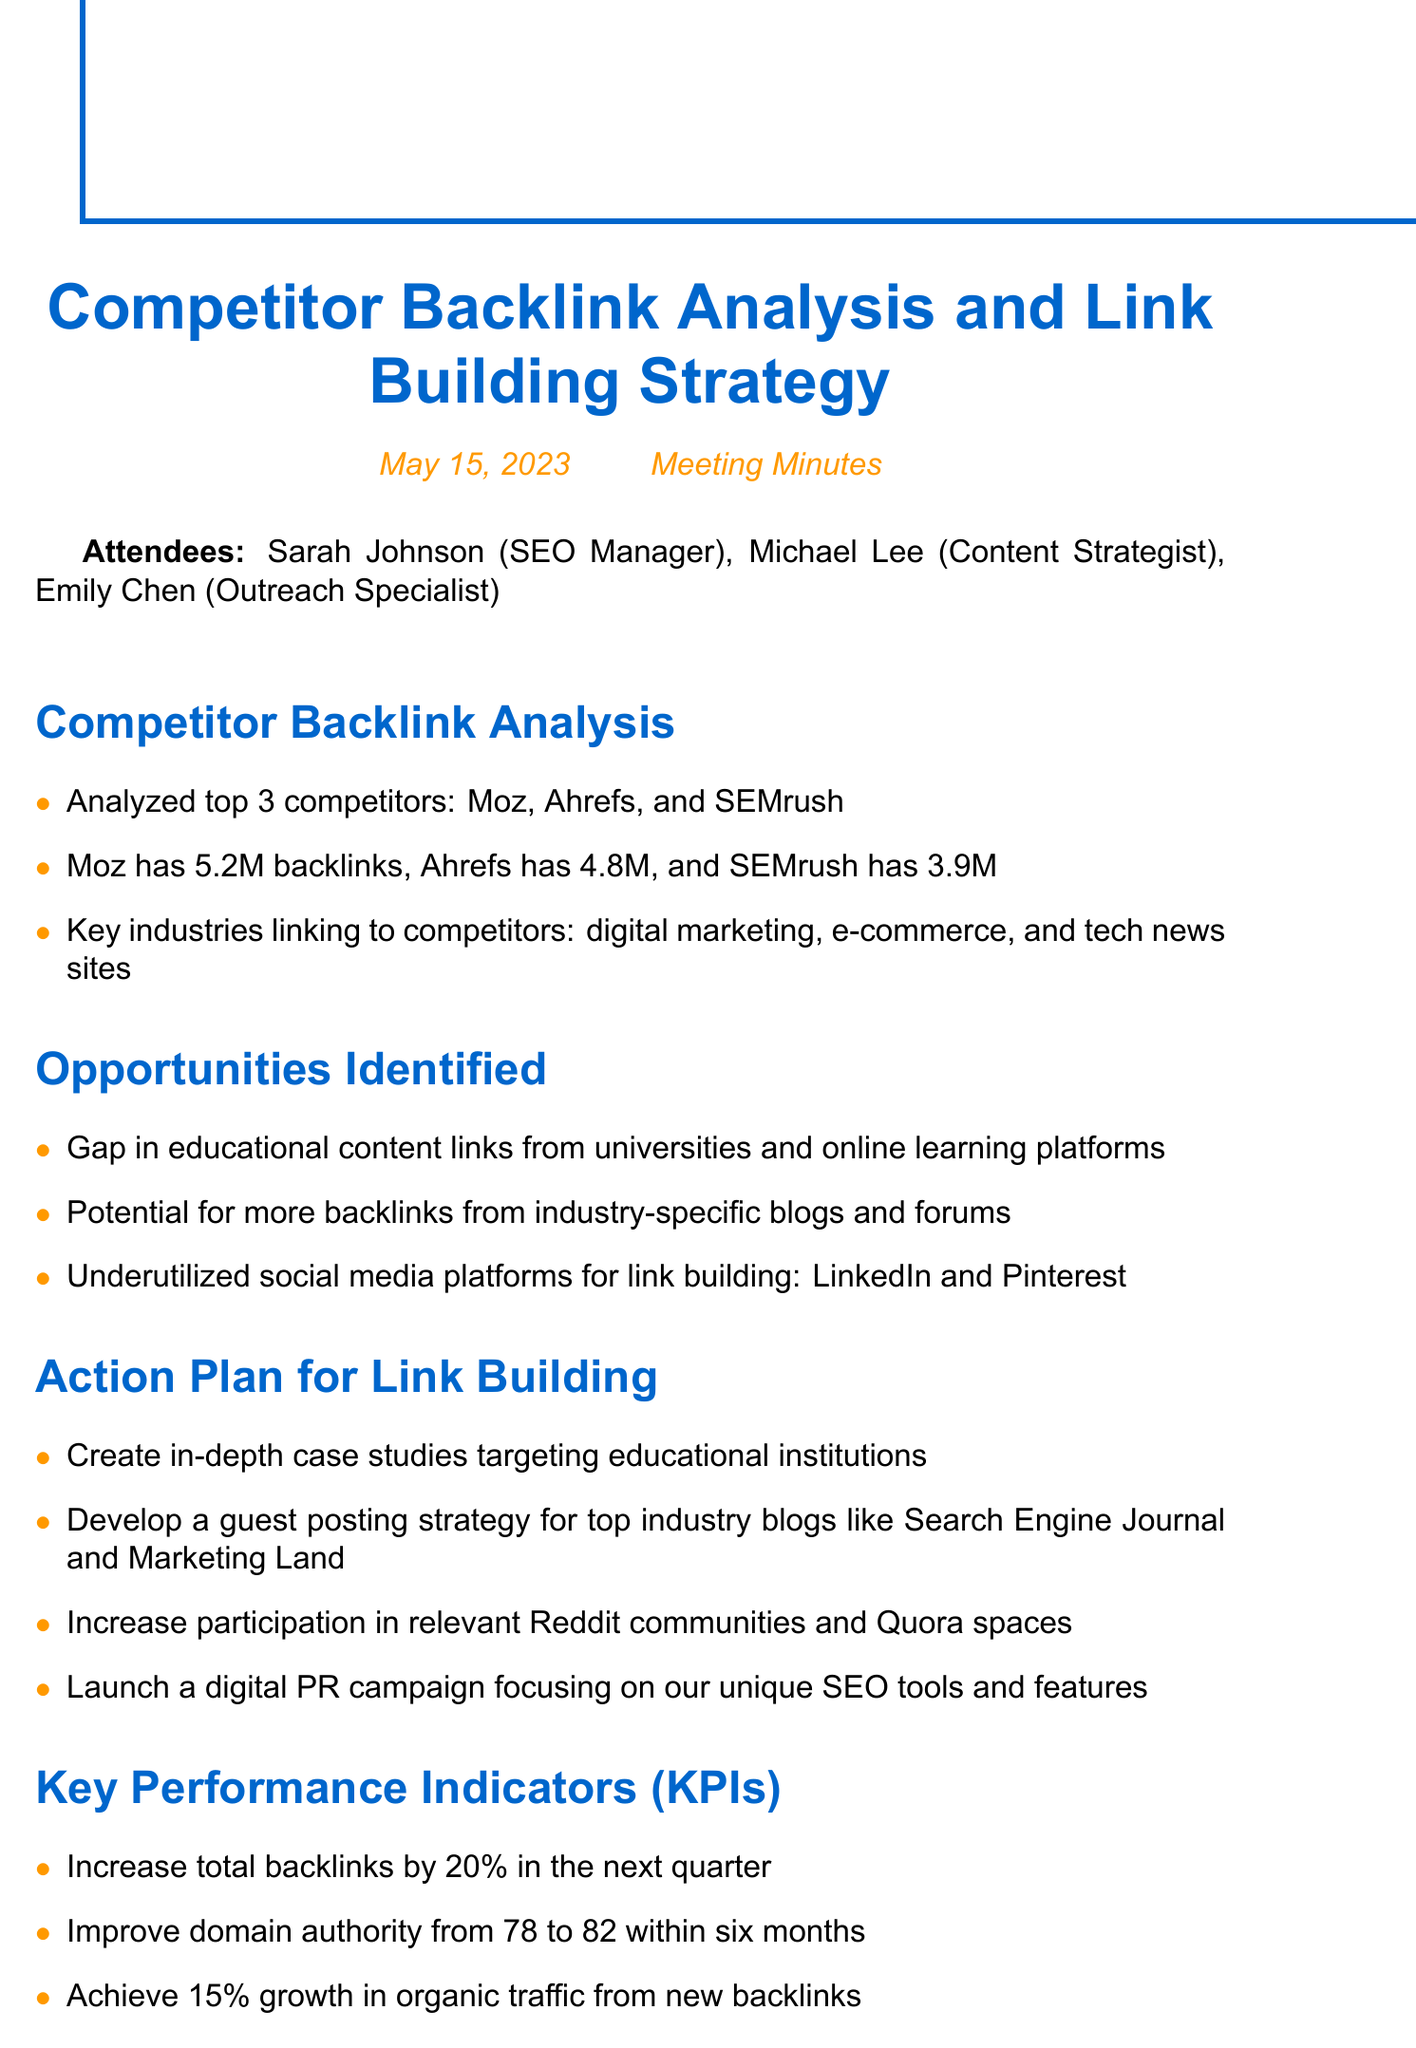What are the top three competitors analyzed? The document lists Moz, Ahrefs, and SEMrush as the top three competitors analyzed.
Answer: Moz, Ahrefs, SEMrush How many backlinks does Moz have? The document states that Moz has 5.2 million backlinks.
Answer: 5.2M What industry has a gap in educational content links? The document highlights a gap in educational content links specifically from universities and online learning platforms.
Answer: Universities and online learning platforms What is the target increase in total backlinks? The document specifies a target increase in total backlinks by 20% in the next quarter.
Answer: 20% Who is responsible for finalizing the link building strategy document? The document assigns the task of finalizing the document to Sarah.
Answer: Sarah What is the current domain authority mentioned? The current domain authority is stated as 78 in the document.
Answer: 78 By when is Emily expected to create a list of top industry blogs? The document indicates that Emily is to create the list by the next steps mentioned, which does not specify an exact date but must be completed as soon as possible.
Answer: Not specified What digital platforms are identified as underutilized for link building? The document mentions LinkedIn and Pinterest as underutilized platforms for link building.
Answer: LinkedIn and Pinterest What is the growth target for organic traffic from new backlinks? The growth target for organic traffic from new backlinks is stated as 15% in the document.
Answer: 15% 